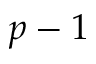<formula> <loc_0><loc_0><loc_500><loc_500>p - 1</formula> 